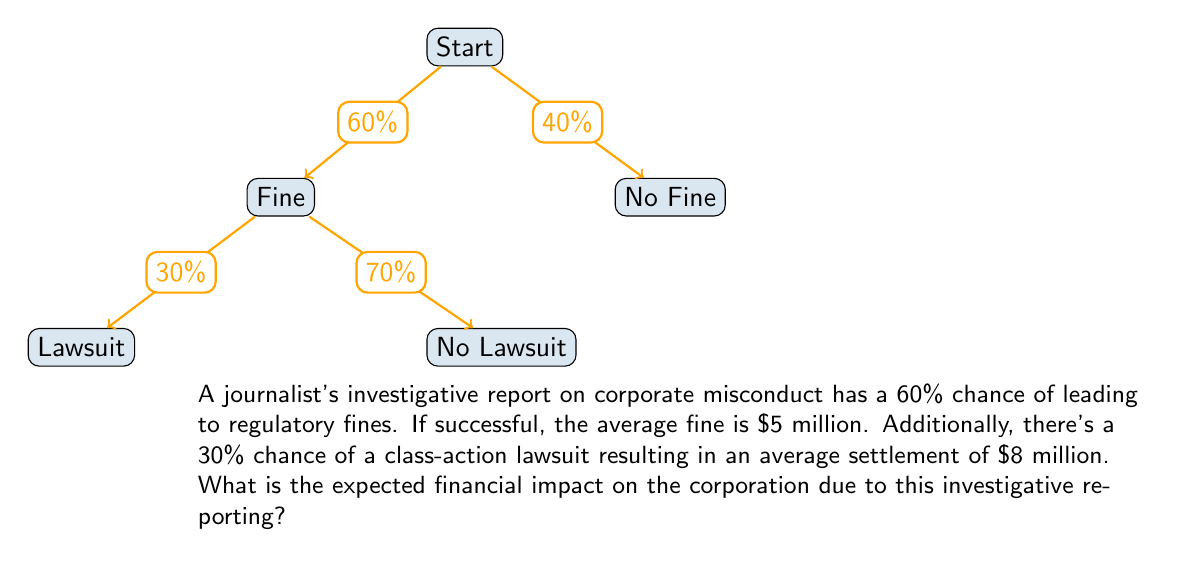Solve this math problem. Let's approach this step-by-step:

1) First, let's calculate the expected value of the regulatory fines:
   $$E(\text{fines}) = 0.60 \times \$5,000,000 = \$3,000,000$$

2) Now, let's calculate the expected value of the lawsuit settlements:
   The probability of a lawsuit is 30% of 60% (as lawsuits only occur if there are fines):
   $$P(\text{lawsuit}) = 0.60 \times 0.30 = 0.18$$
   
   $$E(\text{lawsuit}) = 0.18 \times \$8,000,000 = \$1,440,000$$

3) The total expected financial impact is the sum of these two expected values:
   $$E(\text{total}) = E(\text{fines}) + E(\text{lawsuit})$$
   $$E(\text{total}) = \$3,000,000 + \$1,440,000 = \$4,440,000$$

Therefore, the expected financial impact on the corporation due to this investigative reporting is $4,440,000.
Answer: $4,440,000 